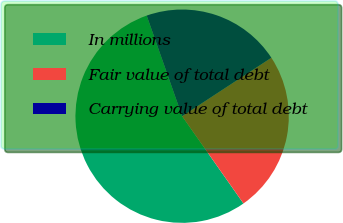<chart> <loc_0><loc_0><loc_500><loc_500><pie_chart><fcel>In millions<fcel>Fair value of total debt<fcel>Carrying value of total debt<nl><fcel>54.35%<fcel>24.48%<fcel>21.16%<nl></chart> 